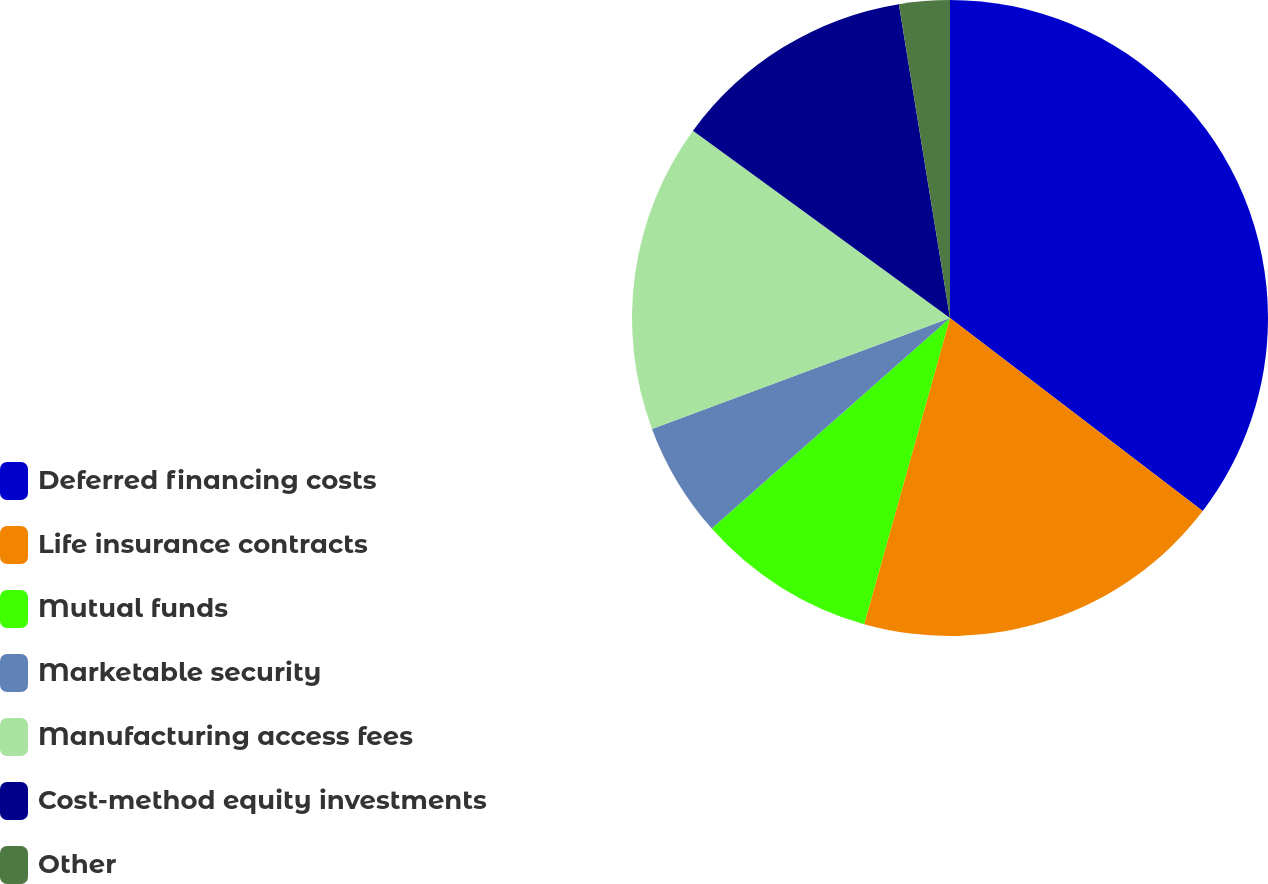Convert chart to OTSL. <chart><loc_0><loc_0><loc_500><loc_500><pie_chart><fcel>Deferred financing costs<fcel>Life insurance contracts<fcel>Mutual funds<fcel>Marketable security<fcel>Manufacturing access fees<fcel>Cost-method equity investments<fcel>Other<nl><fcel>35.38%<fcel>18.97%<fcel>9.13%<fcel>5.85%<fcel>15.69%<fcel>12.41%<fcel>2.57%<nl></chart> 